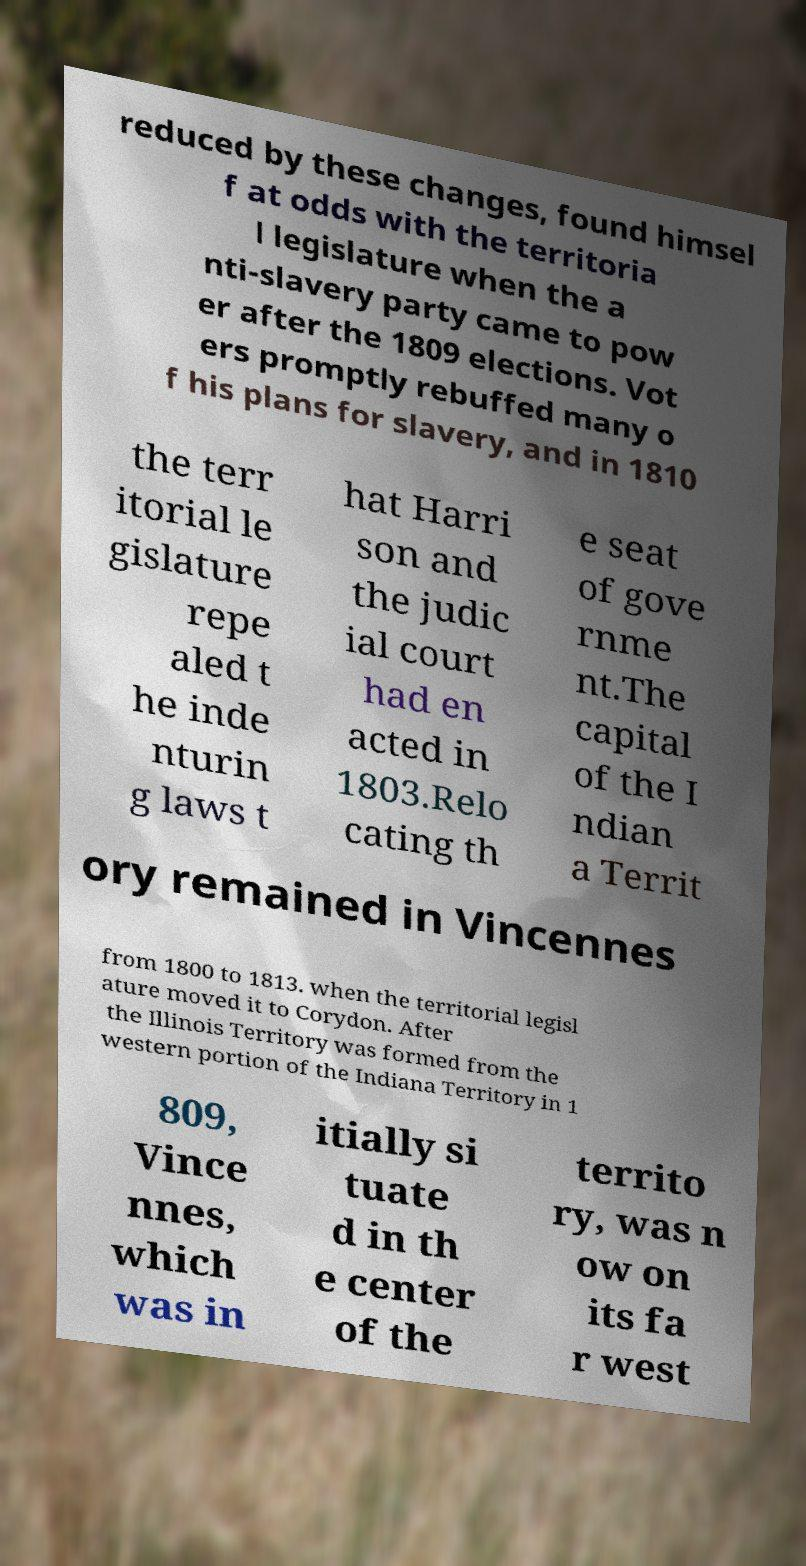Could you extract and type out the text from this image? reduced by these changes, found himsel f at odds with the territoria l legislature when the a nti-slavery party came to pow er after the 1809 elections. Vot ers promptly rebuffed many o f his plans for slavery, and in 1810 the terr itorial le gislature repe aled t he inde nturin g laws t hat Harri son and the judic ial court had en acted in 1803.Relo cating th e seat of gove rnme nt.The capital of the I ndian a Territ ory remained in Vincennes from 1800 to 1813. when the territorial legisl ature moved it to Corydon. After the Illinois Territory was formed from the western portion of the Indiana Territory in 1 809, Vince nnes, which was in itially si tuate d in th e center of the territo ry, was n ow on its fa r west 